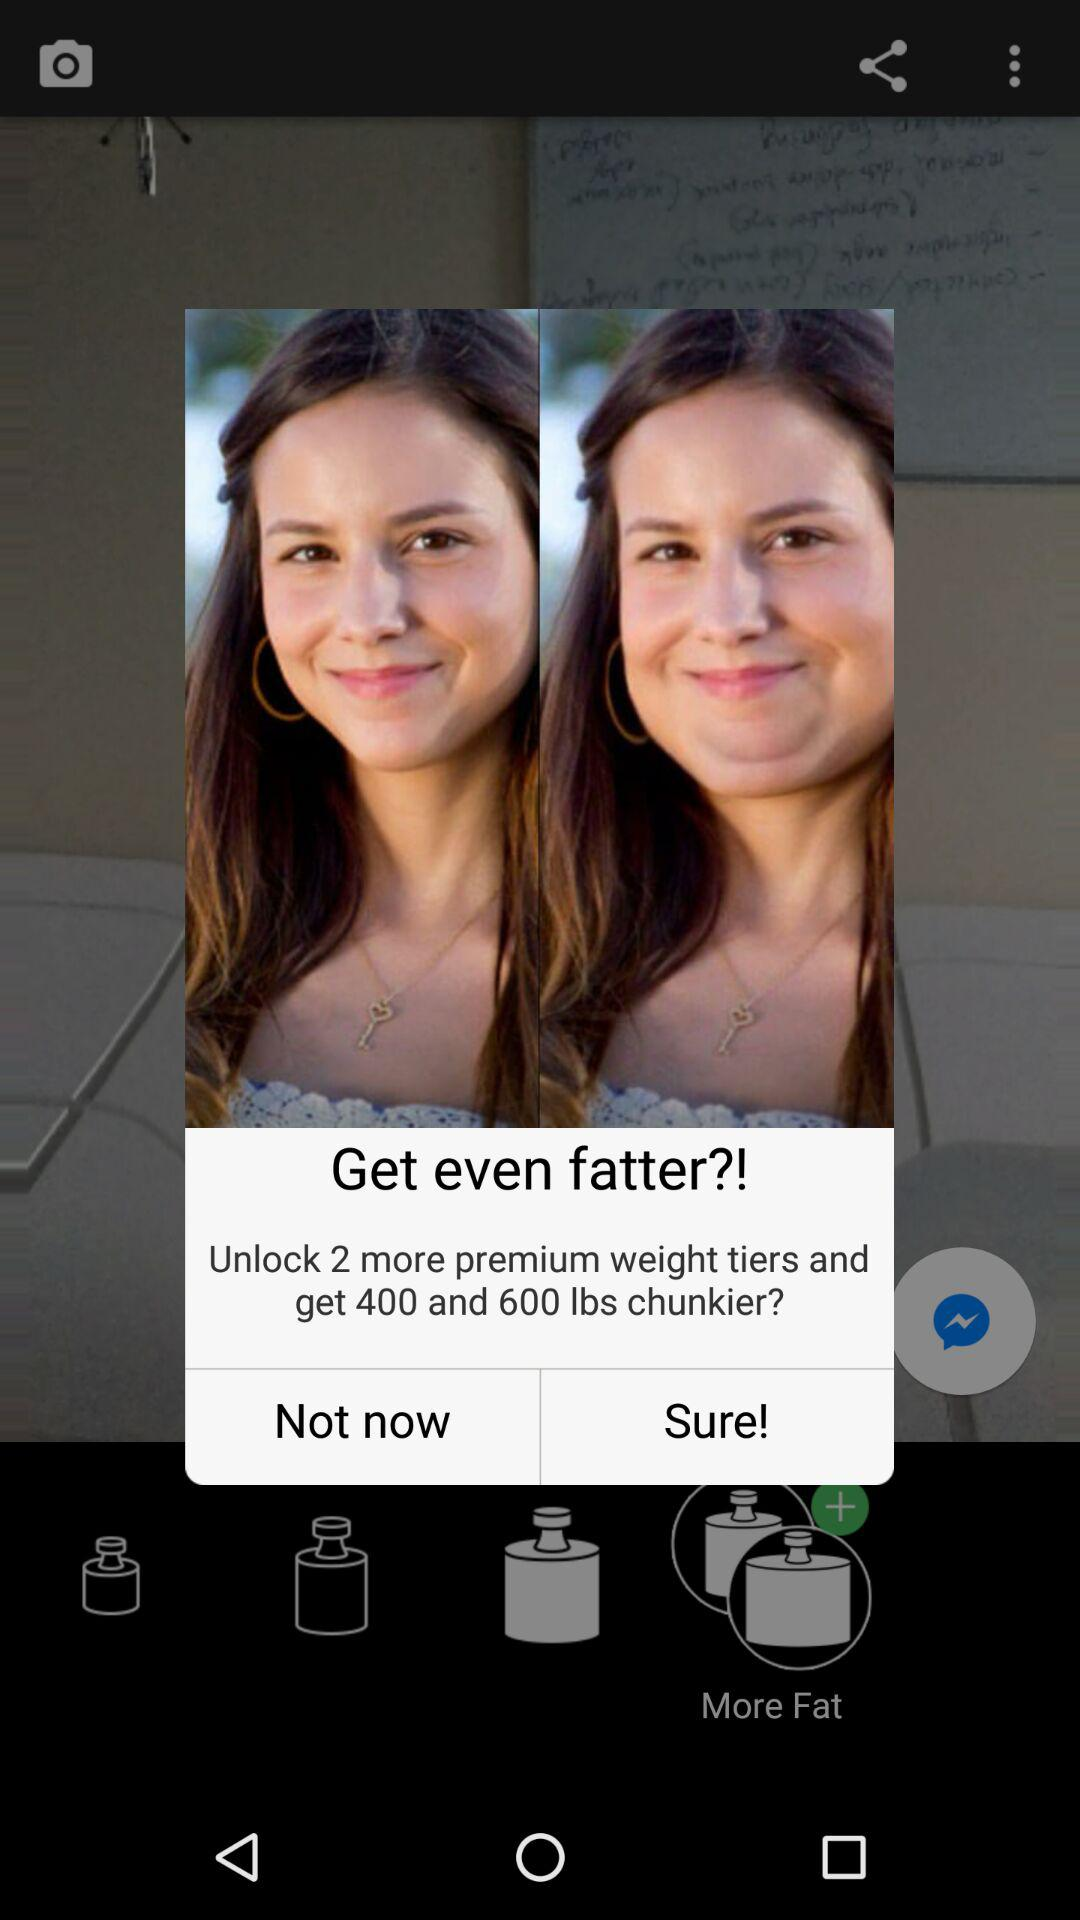How many more weight tiers are available to unlock?
Answer the question using a single word or phrase. 2 